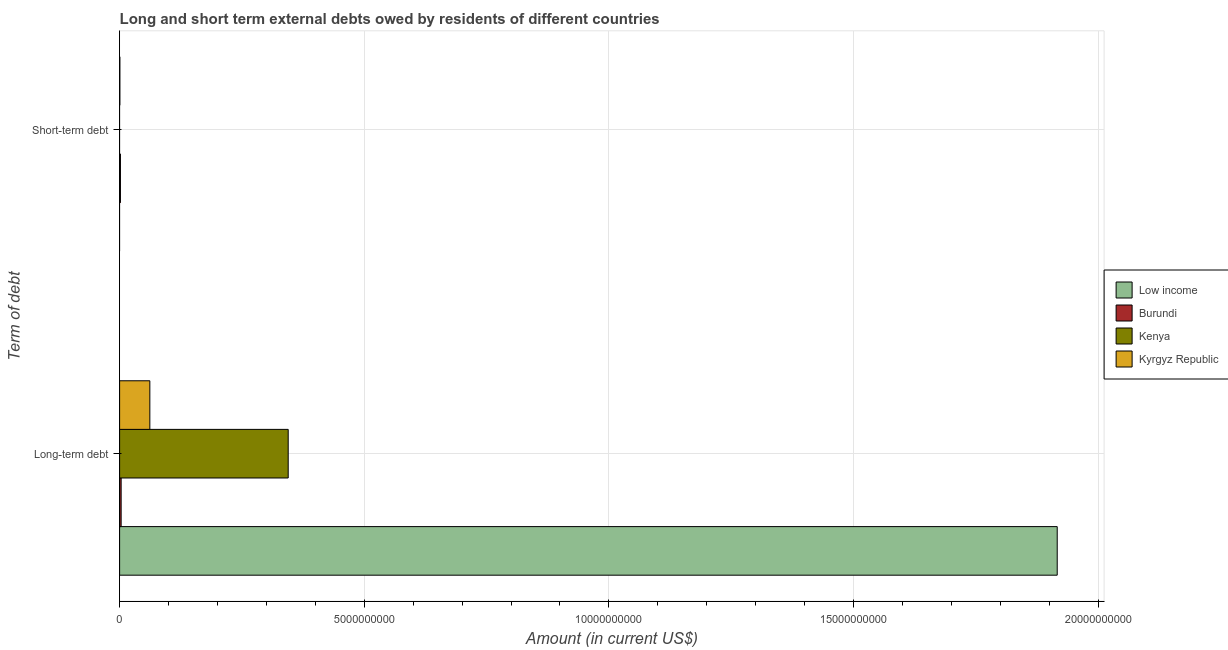How many groups of bars are there?
Your answer should be very brief. 2. Are the number of bars on each tick of the Y-axis equal?
Give a very brief answer. No. How many bars are there on the 1st tick from the bottom?
Provide a succinct answer. 4. What is the label of the 1st group of bars from the top?
Provide a short and direct response. Short-term debt. Across all countries, what is the maximum long-term debts owed by residents?
Your answer should be very brief. 1.92e+1. Across all countries, what is the minimum long-term debts owed by residents?
Make the answer very short. 3.12e+07. What is the total short-term debts owed by residents in the graph?
Offer a terse response. 2.20e+07. What is the difference between the short-term debts owed by residents in Kyrgyz Republic and that in Burundi?
Keep it short and to the point. -1.20e+07. What is the difference between the long-term debts owed by residents in Kenya and the short-term debts owed by residents in Kyrgyz Republic?
Make the answer very short. 3.44e+09. What is the average long-term debts owed by residents per country?
Your answer should be very brief. 5.81e+09. What is the difference between the short-term debts owed by residents and long-term debts owed by residents in Kyrgyz Republic?
Offer a very short reply. -6.13e+08. In how many countries, is the short-term debts owed by residents greater than 10000000000 US$?
Provide a succinct answer. 0. What is the ratio of the long-term debts owed by residents in Burundi to that in Low income?
Offer a terse response. 0. Is the long-term debts owed by residents in Low income less than that in Kenya?
Keep it short and to the point. No. How many bars are there?
Provide a short and direct response. 6. Are all the bars in the graph horizontal?
Your answer should be very brief. Yes. How many countries are there in the graph?
Offer a very short reply. 4. Does the graph contain any zero values?
Provide a succinct answer. Yes. How many legend labels are there?
Keep it short and to the point. 4. What is the title of the graph?
Offer a terse response. Long and short term external debts owed by residents of different countries. What is the label or title of the Y-axis?
Your answer should be very brief. Term of debt. What is the Amount (in current US$) in Low income in Long-term debt?
Make the answer very short. 1.92e+1. What is the Amount (in current US$) of Burundi in Long-term debt?
Provide a succinct answer. 3.12e+07. What is the Amount (in current US$) in Kenya in Long-term debt?
Your answer should be very brief. 3.45e+09. What is the Amount (in current US$) in Kyrgyz Republic in Long-term debt?
Provide a succinct answer. 6.18e+08. What is the Amount (in current US$) in Burundi in Short-term debt?
Give a very brief answer. 1.70e+07. What is the Amount (in current US$) of Kyrgyz Republic in Short-term debt?
Give a very brief answer. 5.00e+06. Across all Term of debt, what is the maximum Amount (in current US$) in Low income?
Provide a short and direct response. 1.92e+1. Across all Term of debt, what is the maximum Amount (in current US$) in Burundi?
Ensure brevity in your answer.  3.12e+07. Across all Term of debt, what is the maximum Amount (in current US$) in Kenya?
Provide a short and direct response. 3.45e+09. Across all Term of debt, what is the maximum Amount (in current US$) in Kyrgyz Republic?
Offer a very short reply. 6.18e+08. Across all Term of debt, what is the minimum Amount (in current US$) in Low income?
Your response must be concise. 0. Across all Term of debt, what is the minimum Amount (in current US$) in Burundi?
Offer a very short reply. 1.70e+07. Across all Term of debt, what is the minimum Amount (in current US$) in Kyrgyz Republic?
Make the answer very short. 5.00e+06. What is the total Amount (in current US$) in Low income in the graph?
Your answer should be compact. 1.92e+1. What is the total Amount (in current US$) in Burundi in the graph?
Keep it short and to the point. 4.82e+07. What is the total Amount (in current US$) of Kenya in the graph?
Ensure brevity in your answer.  3.45e+09. What is the total Amount (in current US$) of Kyrgyz Republic in the graph?
Offer a terse response. 6.23e+08. What is the difference between the Amount (in current US$) of Burundi in Long-term debt and that in Short-term debt?
Make the answer very short. 1.42e+07. What is the difference between the Amount (in current US$) in Kyrgyz Republic in Long-term debt and that in Short-term debt?
Offer a terse response. 6.13e+08. What is the difference between the Amount (in current US$) in Low income in Long-term debt and the Amount (in current US$) in Burundi in Short-term debt?
Offer a very short reply. 1.91e+1. What is the difference between the Amount (in current US$) of Low income in Long-term debt and the Amount (in current US$) of Kyrgyz Republic in Short-term debt?
Offer a very short reply. 1.92e+1. What is the difference between the Amount (in current US$) of Burundi in Long-term debt and the Amount (in current US$) of Kyrgyz Republic in Short-term debt?
Give a very brief answer. 2.62e+07. What is the difference between the Amount (in current US$) of Kenya in Long-term debt and the Amount (in current US$) of Kyrgyz Republic in Short-term debt?
Your answer should be very brief. 3.44e+09. What is the average Amount (in current US$) in Low income per Term of debt?
Your answer should be compact. 9.58e+09. What is the average Amount (in current US$) in Burundi per Term of debt?
Keep it short and to the point. 2.41e+07. What is the average Amount (in current US$) of Kenya per Term of debt?
Offer a very short reply. 1.72e+09. What is the average Amount (in current US$) of Kyrgyz Republic per Term of debt?
Your response must be concise. 3.12e+08. What is the difference between the Amount (in current US$) in Low income and Amount (in current US$) in Burundi in Long-term debt?
Offer a terse response. 1.91e+1. What is the difference between the Amount (in current US$) in Low income and Amount (in current US$) in Kenya in Long-term debt?
Your answer should be compact. 1.57e+1. What is the difference between the Amount (in current US$) in Low income and Amount (in current US$) in Kyrgyz Republic in Long-term debt?
Offer a very short reply. 1.85e+1. What is the difference between the Amount (in current US$) of Burundi and Amount (in current US$) of Kenya in Long-term debt?
Give a very brief answer. -3.41e+09. What is the difference between the Amount (in current US$) in Burundi and Amount (in current US$) in Kyrgyz Republic in Long-term debt?
Keep it short and to the point. -5.87e+08. What is the difference between the Amount (in current US$) in Kenya and Amount (in current US$) in Kyrgyz Republic in Long-term debt?
Offer a very short reply. 2.83e+09. What is the ratio of the Amount (in current US$) in Burundi in Long-term debt to that in Short-term debt?
Give a very brief answer. 1.84. What is the ratio of the Amount (in current US$) of Kyrgyz Republic in Long-term debt to that in Short-term debt?
Your answer should be very brief. 123.6. What is the difference between the highest and the second highest Amount (in current US$) in Burundi?
Offer a very short reply. 1.42e+07. What is the difference between the highest and the second highest Amount (in current US$) of Kyrgyz Republic?
Offer a very short reply. 6.13e+08. What is the difference between the highest and the lowest Amount (in current US$) of Low income?
Offer a terse response. 1.92e+1. What is the difference between the highest and the lowest Amount (in current US$) of Burundi?
Offer a very short reply. 1.42e+07. What is the difference between the highest and the lowest Amount (in current US$) of Kenya?
Your answer should be very brief. 3.45e+09. What is the difference between the highest and the lowest Amount (in current US$) of Kyrgyz Republic?
Offer a terse response. 6.13e+08. 